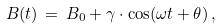<formula> <loc_0><loc_0><loc_500><loc_500>B ( t ) \, = \, B _ { 0 } + \gamma \cdot \cos ( \omega t + \theta ) \, ,</formula> 